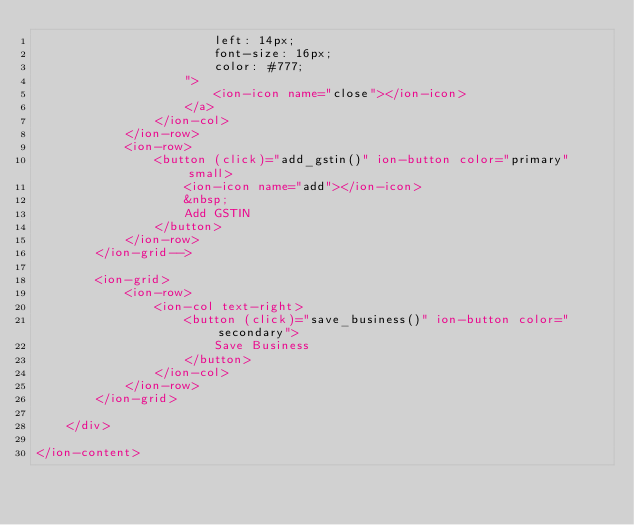<code> <loc_0><loc_0><loc_500><loc_500><_HTML_>						left: 14px;
						font-size: 16px;
						color: #777;
					">
						<ion-icon name="close"></ion-icon>
					</a>
				</ion-col>
			</ion-row>
			<ion-row>
				<button (click)="add_gstin()" ion-button color="primary" small>
					<ion-icon name="add"></ion-icon>
					&nbsp;
					Add GSTIN
				</button>
			</ion-row>
		</ion-grid-->
		
		<ion-grid>
			<ion-row>
				<ion-col text-right>
					<button (click)="save_business()" ion-button color="secondary">
						Save Business
					</button>
				</ion-col>
			</ion-row>
		</ion-grid>
		
	</div>

</ion-content></code> 